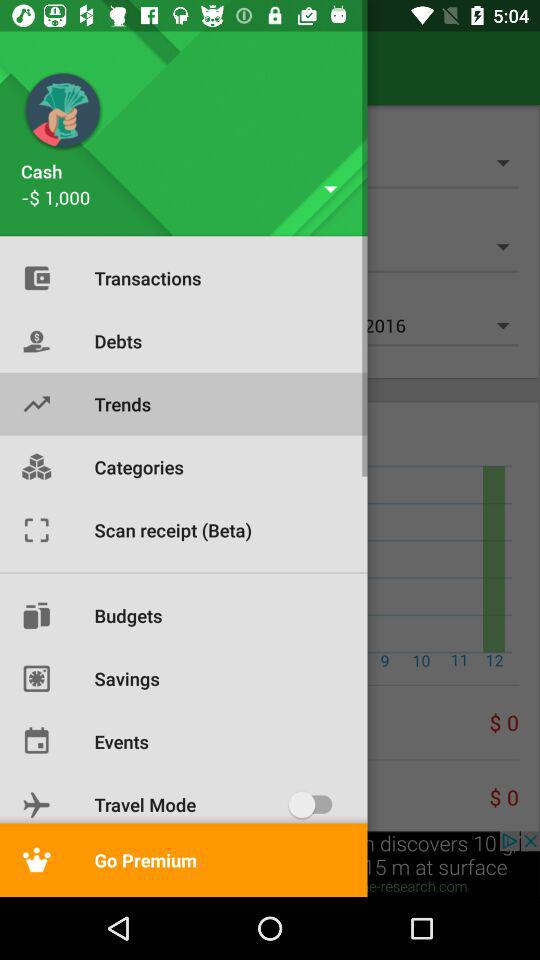Which item is selected in the menu? The selected item in the menu is "Trends". 